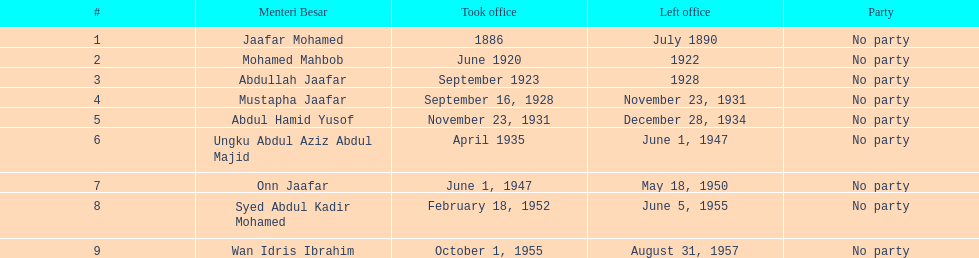What is the count of menteri besars during the pre-independence era? 9. 